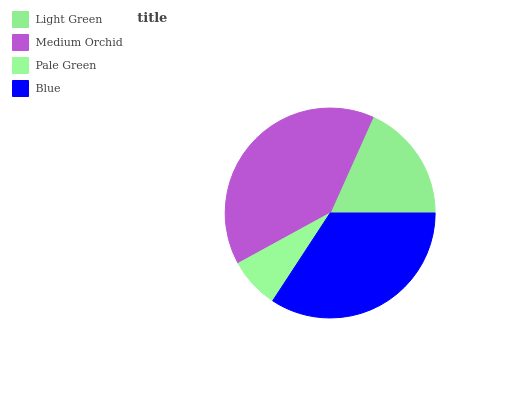Is Pale Green the minimum?
Answer yes or no. Yes. Is Medium Orchid the maximum?
Answer yes or no. Yes. Is Medium Orchid the minimum?
Answer yes or no. No. Is Pale Green the maximum?
Answer yes or no. No. Is Medium Orchid greater than Pale Green?
Answer yes or no. Yes. Is Pale Green less than Medium Orchid?
Answer yes or no. Yes. Is Pale Green greater than Medium Orchid?
Answer yes or no. No. Is Medium Orchid less than Pale Green?
Answer yes or no. No. Is Blue the high median?
Answer yes or no. Yes. Is Light Green the low median?
Answer yes or no. Yes. Is Light Green the high median?
Answer yes or no. No. Is Blue the low median?
Answer yes or no. No. 